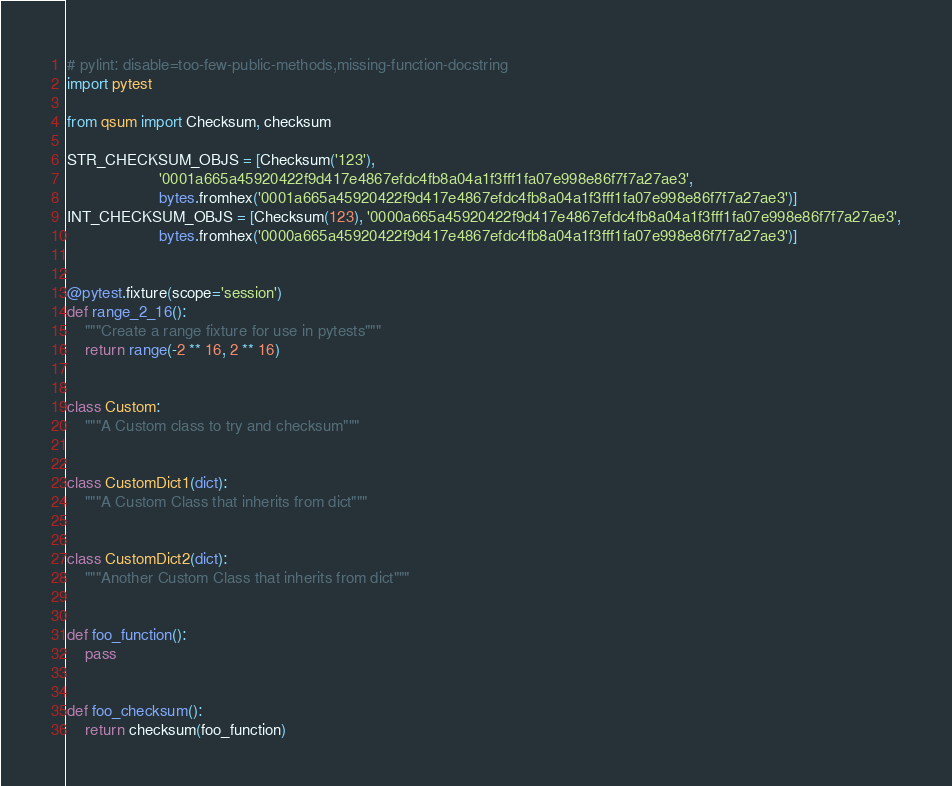Convert code to text. <code><loc_0><loc_0><loc_500><loc_500><_Python_># pylint: disable=too-few-public-methods,missing-function-docstring
import pytest

from qsum import Checksum, checksum

STR_CHECKSUM_OBJS = [Checksum('123'),
                     '0001a665a45920422f9d417e4867efdc4fb8a04a1f3fff1fa07e998e86f7f7a27ae3',
                     bytes.fromhex('0001a665a45920422f9d417e4867efdc4fb8a04a1f3fff1fa07e998e86f7f7a27ae3')]
INT_CHECKSUM_OBJS = [Checksum(123), '0000a665a45920422f9d417e4867efdc4fb8a04a1f3fff1fa07e998e86f7f7a27ae3',
                     bytes.fromhex('0000a665a45920422f9d417e4867efdc4fb8a04a1f3fff1fa07e998e86f7f7a27ae3')]


@pytest.fixture(scope='session')
def range_2_16():
    """Create a range fixture for use in pytests"""
    return range(-2 ** 16, 2 ** 16)


class Custom:
    """A Custom class to try and checksum"""


class CustomDict1(dict):
    """A Custom Class that inherits from dict"""


class CustomDict2(dict):
    """Another Custom Class that inherits from dict"""


def foo_function():
    pass


def foo_checksum():
    return checksum(foo_function)
</code> 